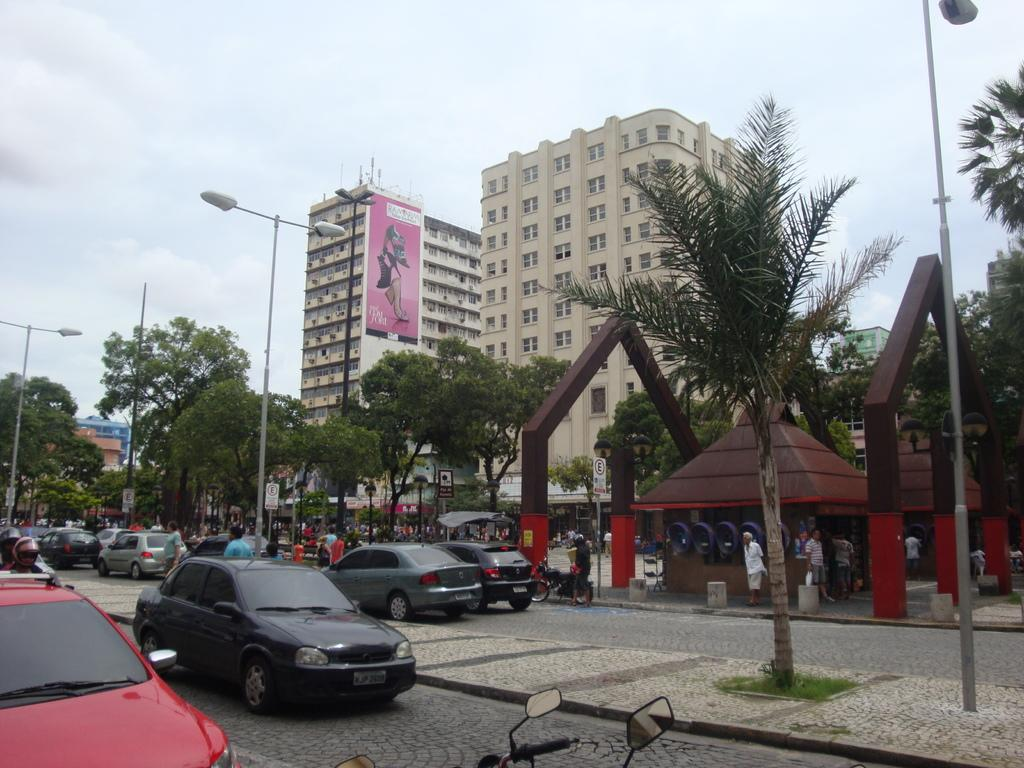What is the weather condition in the image? The sky is cloudy in the image. What type of structures can be seen in the image? There are buildings with windows in the image. What is the advertisement medium present in the image? There is a hoarding in the image. What type of vegetation is present in the image? Trees are present in the image. What type of street furniture is visible in the image? Light poles are visible in the image. What type of transportation is present in the image? Vehicles are on the road in the image. What type of living organisms are present in the image? People are present in the image. What type of information medium is visible in the image? Sign boards are visible in the image. Where is the cave located in the image? There is no cave present in the image. What type of tool is being used by the ducks in the image? There are no ducks or tools present in the image. 